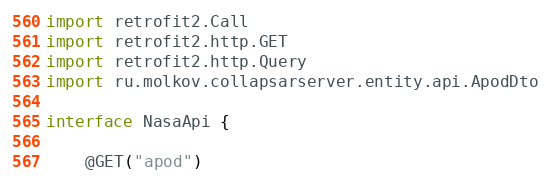Convert code to text. <code><loc_0><loc_0><loc_500><loc_500><_Kotlin_>
import retrofit2.Call
import retrofit2.http.GET
import retrofit2.http.Query
import ru.molkov.collapsarserver.entity.api.ApodDto

interface NasaApi {

    @GET("apod")</code> 